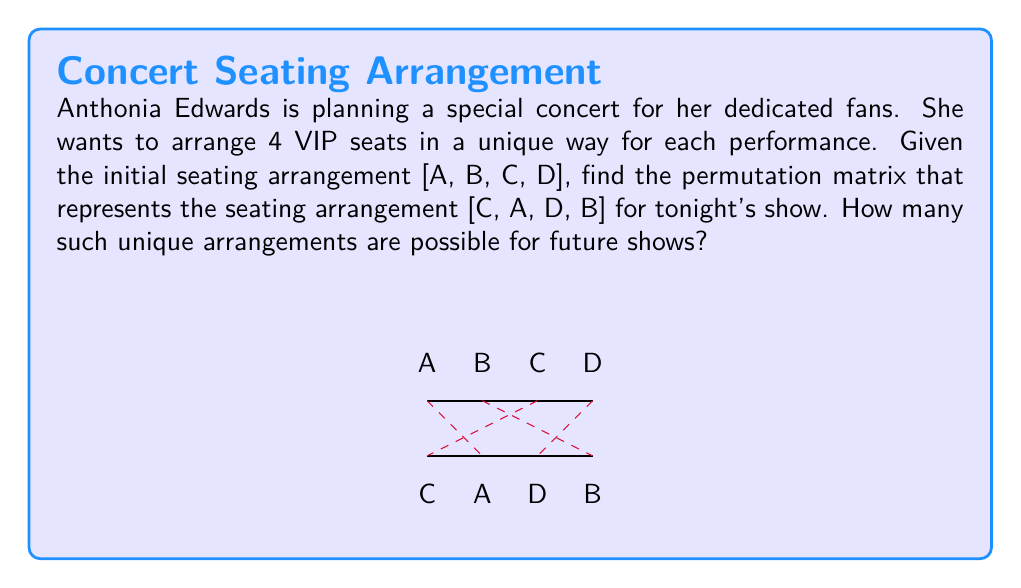Could you help me with this problem? Let's approach this step-by-step:

1) A permutation matrix is a square binary matrix that has exactly one entry of 1 in each row and each column, and 0s elsewhere.

2) To find the permutation matrix, we need to map the initial arrangement [A, B, C, D] to the new arrangement [C, A, D, B].

3) The permutation matrix P will be a 4x4 matrix where:
   - Row 1 represents where A moves to (2nd position)
   - Row 2 represents where B moves to (4th position)
   - Row 3 represents where C moves to (1st position)
   - Row 4 represents where D moves to (3rd position)

4) Therefore, the permutation matrix P is:

   $$P = \begin{bmatrix}
   0 & 1 & 0 & 0 \\
   0 & 0 & 0 & 1 \\
   1 & 0 & 0 & 0 \\
   0 & 0 & 1 & 0
   \end{bmatrix}$$

5) To verify, we can multiply this matrix with the initial arrangement:

   $$P \begin{bmatrix} A \\ B \\ C \\ D \end{bmatrix} = \begin{bmatrix} C \\ A \\ D \\ B \end{bmatrix}$$

6) For the second part of the question, we need to calculate the total number of possible unique arrangements.

7) This is a permutation problem. With 4 distinct seats, the number of possible arrangements is 4! (4 factorial).

8) 4! = 4 × 3 × 2 × 1 = 24

Therefore, there are 24 possible unique arrangements for future shows.
Answer: $P = \begin{bmatrix} 0 & 1 & 0 & 0 \\ 0 & 0 & 0 & 1 \\ 1 & 0 & 0 & 0 \\ 0 & 0 & 1 & 0 \end{bmatrix}$; 24 unique arrangements 